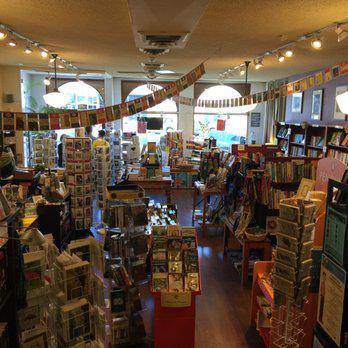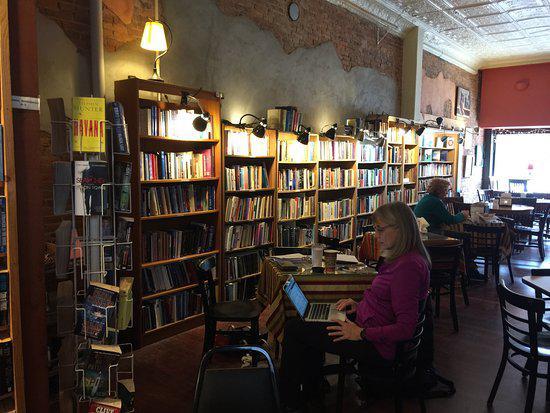The first image is the image on the left, the second image is the image on the right. Evaluate the accuracy of this statement regarding the images: "There are at least two chairs.". Is it true? Answer yes or no. Yes. 